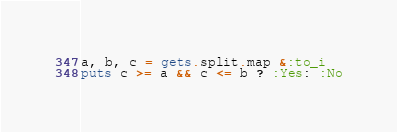Convert code to text. <code><loc_0><loc_0><loc_500><loc_500><_Ruby_>a, b, c = gets.split.map &:to_i
puts c >= a && c <= b ? :Yes: :No</code> 